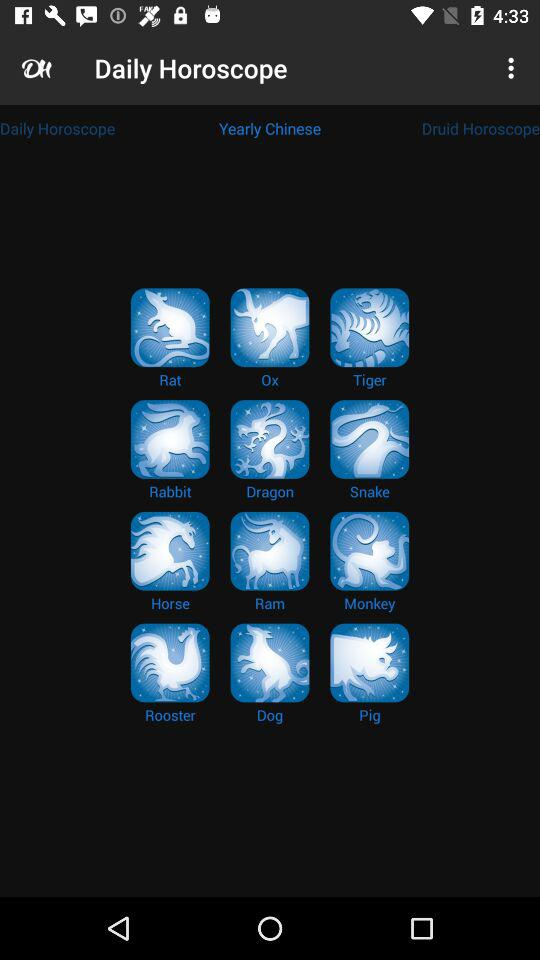Which tab has been selected? The selected tab is "Yearly Chinese". 